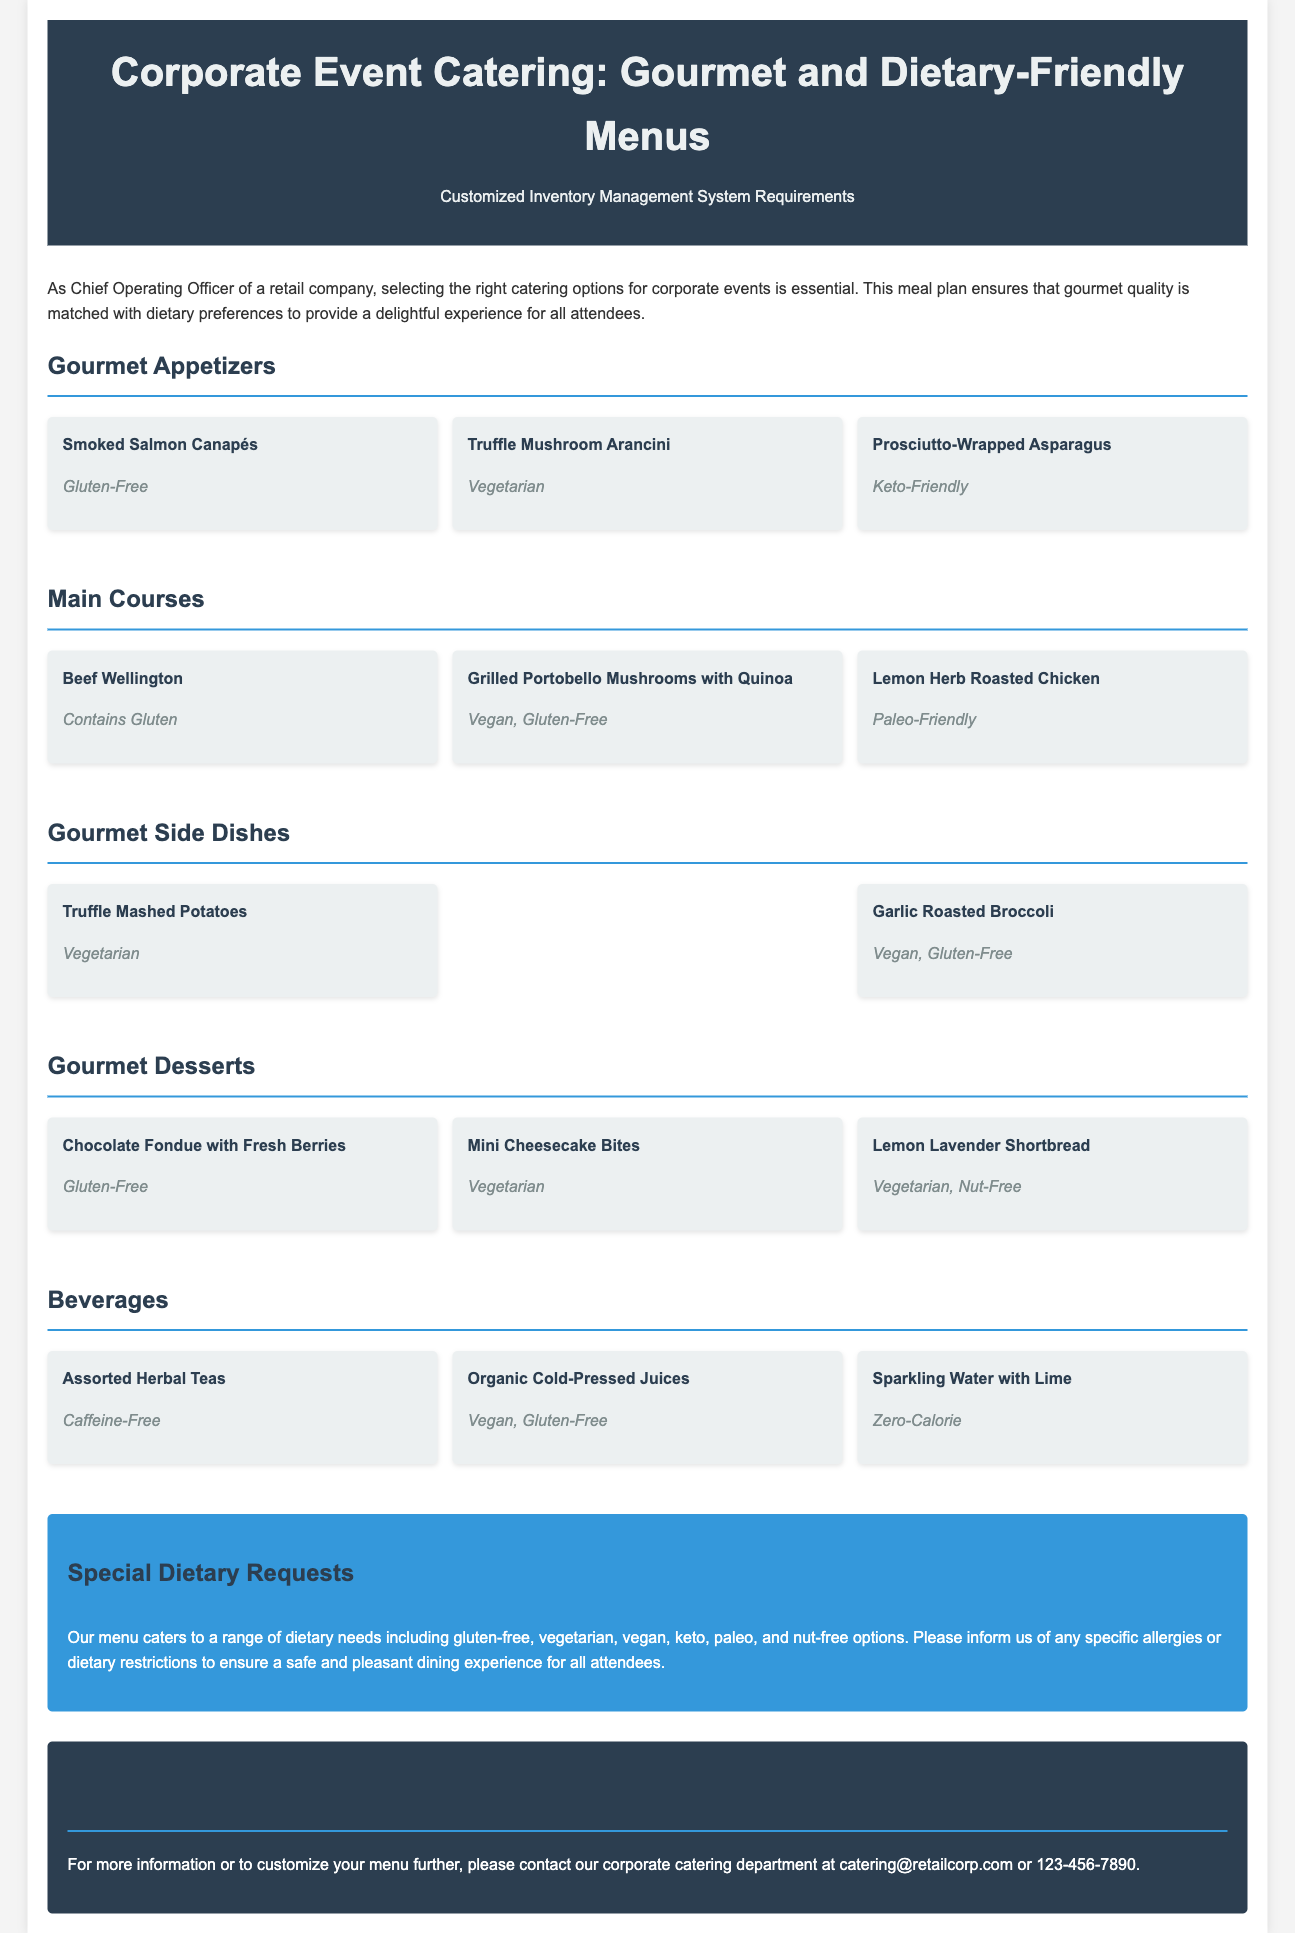What is the title of the document? The title is in the header section, indicating the subject of the document.
Answer: Corporate Event Catering: Gourmet and Dietary-Friendly Menus How many gourmet appetizers are listed? The document states the number of gourmet appetizers in the respective section which lists three items.
Answer: 3 What type of dietary-friendly option is the "Grilled Portobello Mushrooms with Quinoa"? The dietary-friendly options are mentioned in parentheses next to each menu item.
Answer: Vegan, Gluten-Free Name one gluten-free dessert from the menu. The dessert menu section contains multiple items, and one of them is specified as gluten-free.
Answer: Chocolate Fondue with Fresh Berries What dietary requests do they accommodate? The special dietary requests section enumerates the possible accommodations available in the catering menu.
Answer: Gluten-free, vegetarian, vegan, keto, paleo, nut-free How can you contact the corporate catering department? Contact information is provided in a specific section, detailing how to reach the catering department.
Answer: catering@retailcorp.com What is included in the beverages section? The beverages section details specific drink options available at the event.
Answer: Assorted Herbal Teas, Organic Cold-Pressed Juices, Sparkling Water with Lime Which dish contains gluten? Dietary information is specified for each dish, and one is indicated to contain gluten.
Answer: Beef Wellington What type of cuisine does this meal plan focus on? The introductory paragraph outlines the primary focus of the meal plan regarding food quality and style.
Answer: Gourmet 